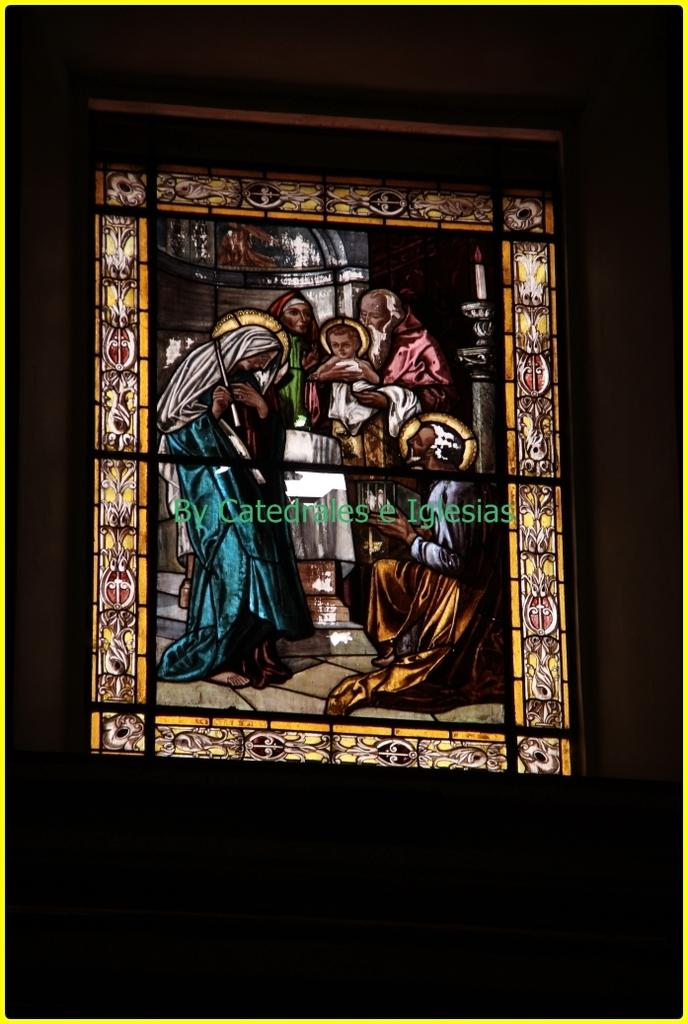What type of artwork is featured in the image? There is a glass painting in the image. Can you describe any additional details about the glass painting? The glass painting has some text on it. How many clouds can be seen in the glass painting? There are no clouds visible in the glass painting, as it is a text-based artwork. 